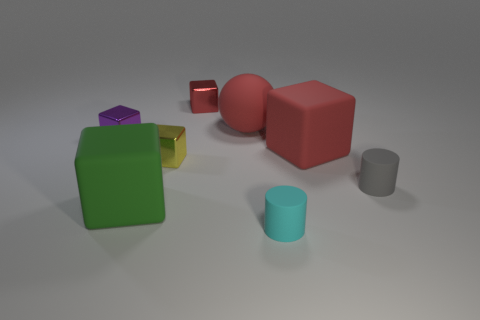What is the material of the gray cylinder?
Your response must be concise. Rubber. What size is the purple metal thing that is the same shape as the red metal object?
Provide a short and direct response. Small. How many other objects are there of the same material as the tiny yellow object?
Provide a short and direct response. 2. Are there the same number of big cubes that are to the right of the gray rubber cylinder and brown spheres?
Provide a short and direct response. Yes. There is a matte cube that is to the right of the cyan matte cylinder; does it have the same size as the big ball?
Your response must be concise. Yes. There is a tiny purple metal object; what number of purple objects are left of it?
Your answer should be compact. 0. There is a tiny thing that is behind the large green thing and on the right side of the rubber ball; what is its material?
Give a very brief answer. Rubber. How many big things are yellow metal spheres or gray rubber objects?
Make the answer very short. 0. The red metal thing has what size?
Offer a very short reply. Small. There is a yellow thing; what shape is it?
Your answer should be very brief. Cube. 